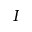Convert formula to latex. <formula><loc_0><loc_0><loc_500><loc_500>I</formula> 